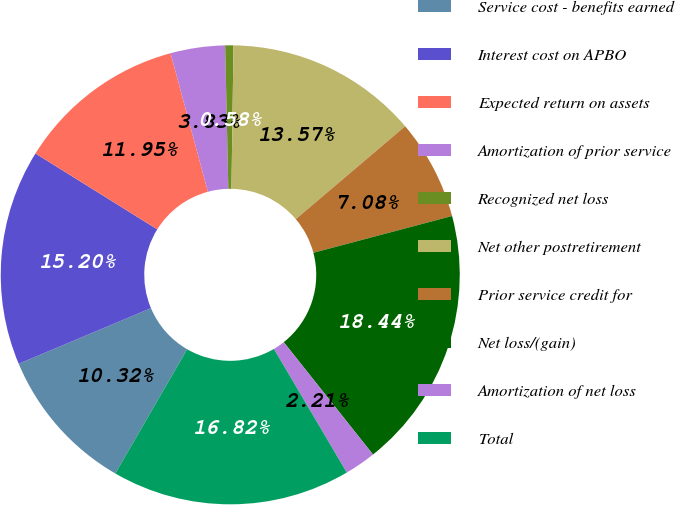Convert chart. <chart><loc_0><loc_0><loc_500><loc_500><pie_chart><fcel>Service cost - benefits earned<fcel>Interest cost on APBO<fcel>Expected return on assets<fcel>Amortization of prior service<fcel>Recognized net loss<fcel>Net other postretirement<fcel>Prior service credit for<fcel>Net loss/(gain)<fcel>Amortization of net loss<fcel>Total<nl><fcel>10.32%<fcel>15.2%<fcel>11.95%<fcel>3.83%<fcel>0.58%<fcel>13.57%<fcel>7.08%<fcel>18.44%<fcel>2.21%<fcel>16.82%<nl></chart> 